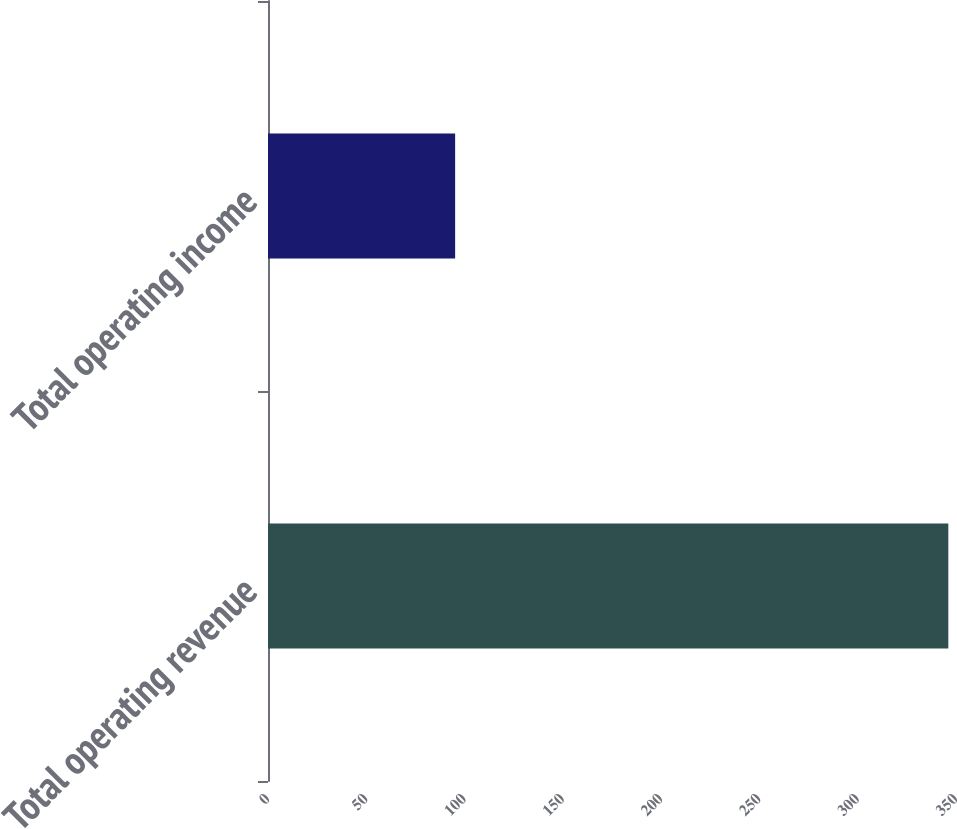Convert chart to OTSL. <chart><loc_0><loc_0><loc_500><loc_500><bar_chart><fcel>Total operating revenue<fcel>Total operating income<nl><fcel>346.1<fcel>95.2<nl></chart> 